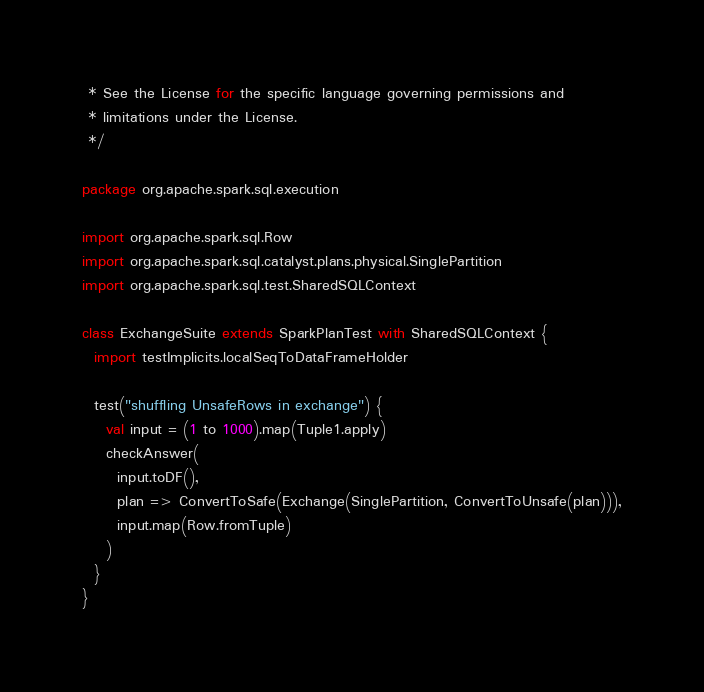<code> <loc_0><loc_0><loc_500><loc_500><_Scala_> * See the License for the specific language governing permissions and
 * limitations under the License.
 */

package org.apache.spark.sql.execution

import org.apache.spark.sql.Row
import org.apache.spark.sql.catalyst.plans.physical.SinglePartition
import org.apache.spark.sql.test.SharedSQLContext

class ExchangeSuite extends SparkPlanTest with SharedSQLContext {
  import testImplicits.localSeqToDataFrameHolder

  test("shuffling UnsafeRows in exchange") {
    val input = (1 to 1000).map(Tuple1.apply)
    checkAnswer(
      input.toDF(),
      plan => ConvertToSafe(Exchange(SinglePartition, ConvertToUnsafe(plan))),
      input.map(Row.fromTuple)
    )
  }
}
</code> 